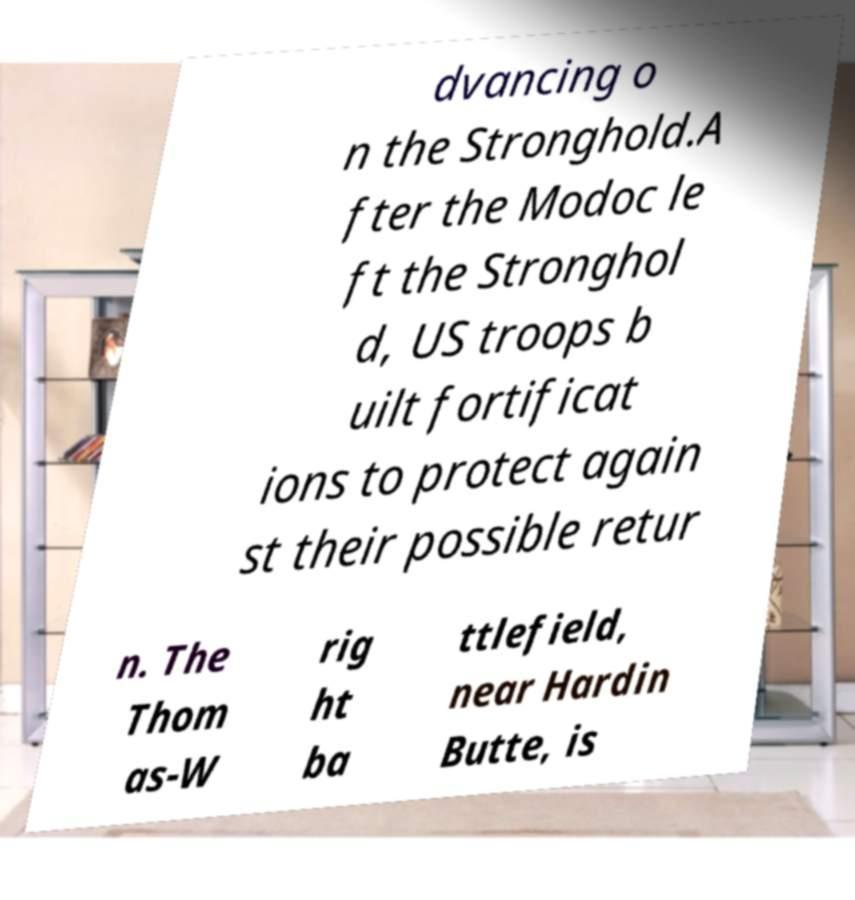Please read and relay the text visible in this image. What does it say? dvancing o n the Stronghold.A fter the Modoc le ft the Stronghol d, US troops b uilt fortificat ions to protect again st their possible retur n. The Thom as-W rig ht ba ttlefield, near Hardin Butte, is 